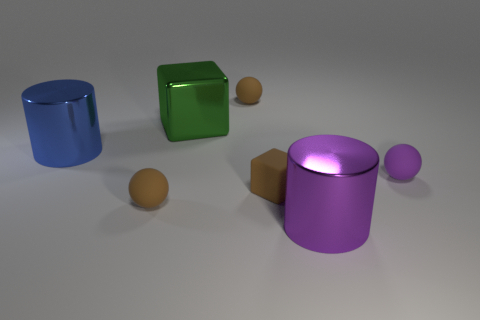There is a blue cylinder that is on the left side of the green block; what size is it?
Give a very brief answer. Large. There is a shiny cylinder that is left of the green block; does it have the same color as the small rubber sphere that is in front of the tiny purple rubber ball?
Give a very brief answer. No. How many other things are there of the same shape as the large blue thing?
Give a very brief answer. 1. Is the number of green cubes in front of the big blue metal thing the same as the number of green metallic blocks right of the purple shiny object?
Your answer should be very brief. Yes. Are the large cylinder that is on the right side of the brown cube and the sphere behind the tiny purple rubber sphere made of the same material?
Ensure brevity in your answer.  No. How many other objects are there of the same size as the purple rubber thing?
Keep it short and to the point. 3. What number of objects are green cubes or big metallic cylinders in front of the big blue object?
Your answer should be very brief. 2. Is the number of matte balls that are in front of the big purple metal object the same as the number of brown rubber blocks?
Keep it short and to the point. No. What shape is the large green object that is made of the same material as the large blue object?
Your response must be concise. Cube. Is there another matte cube of the same color as the rubber block?
Offer a very short reply. No. 